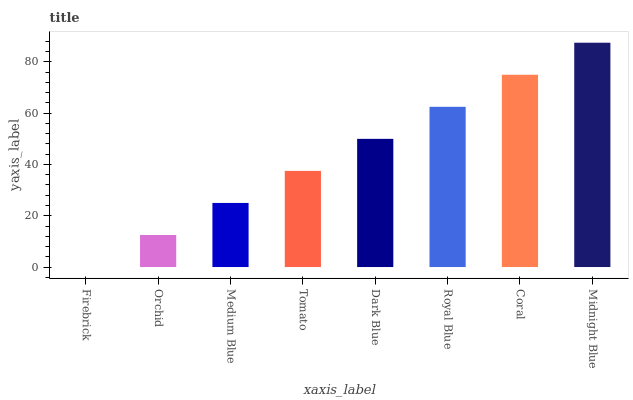Is Firebrick the minimum?
Answer yes or no. Yes. Is Midnight Blue the maximum?
Answer yes or no. Yes. Is Orchid the minimum?
Answer yes or no. No. Is Orchid the maximum?
Answer yes or no. No. Is Orchid greater than Firebrick?
Answer yes or no. Yes. Is Firebrick less than Orchid?
Answer yes or no. Yes. Is Firebrick greater than Orchid?
Answer yes or no. No. Is Orchid less than Firebrick?
Answer yes or no. No. Is Dark Blue the high median?
Answer yes or no. Yes. Is Tomato the low median?
Answer yes or no. Yes. Is Royal Blue the high median?
Answer yes or no. No. Is Royal Blue the low median?
Answer yes or no. No. 